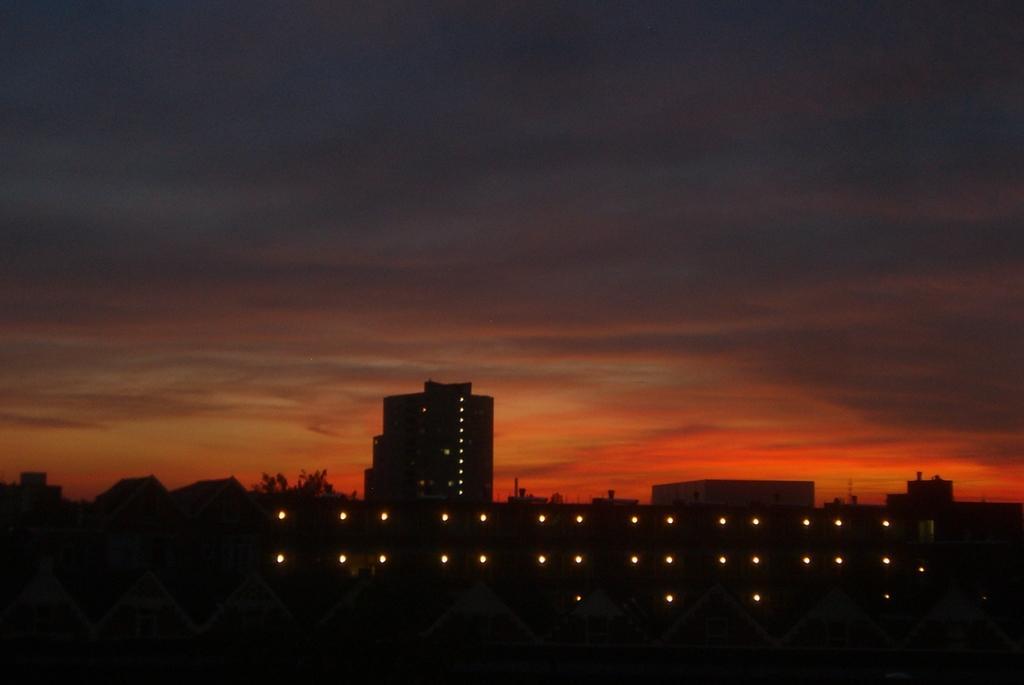Describe this image in one or two sentences. There are lights arranged. In the background, there are lights on the building, there are buildings, trees and clouds in the sky. 